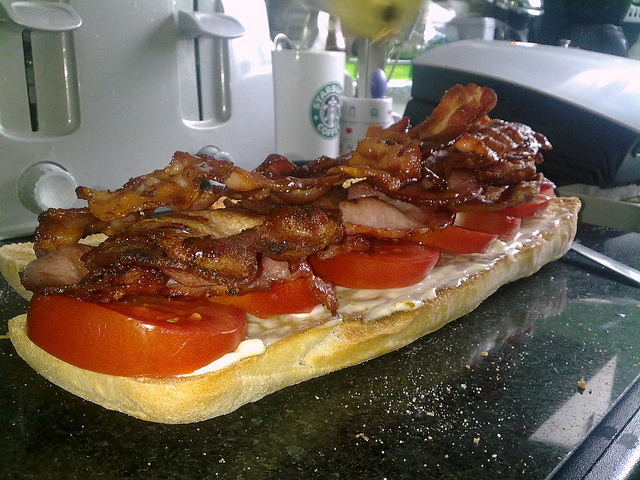Can you describe what's happening in this image? In this image, a sandwich is being prepared on what appears to be a kitchen counter. The bread is loaded with freshly sliced tomatoes, mayonnaise, and a heap of crispy bacon. The backdrop includes a stainless steel toaster, a coffee mug with a familiar coffee shop logo, and various other kitchen items, indicating a casual morning breakfast or snack preparation scene. What other ingredients would you add to this sandwich? To enhance this already tantalizing sandwich, one could add some fresh lettuce, a few slices of avocado for creaminess, or perhaps some cheese, such as cheddar or mozzarella. For a bit of a kick, a drizzle of spicy sriracha sauce or a sprinkle of black pepper could also be a great addition. 